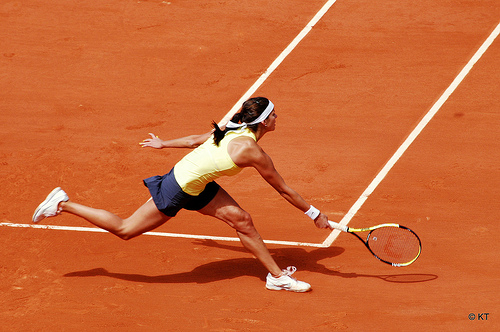What is the activity being performed in the image? The person in the image is engaged in playing tennis, specifically reaching out to make a powerful backhand shot. 